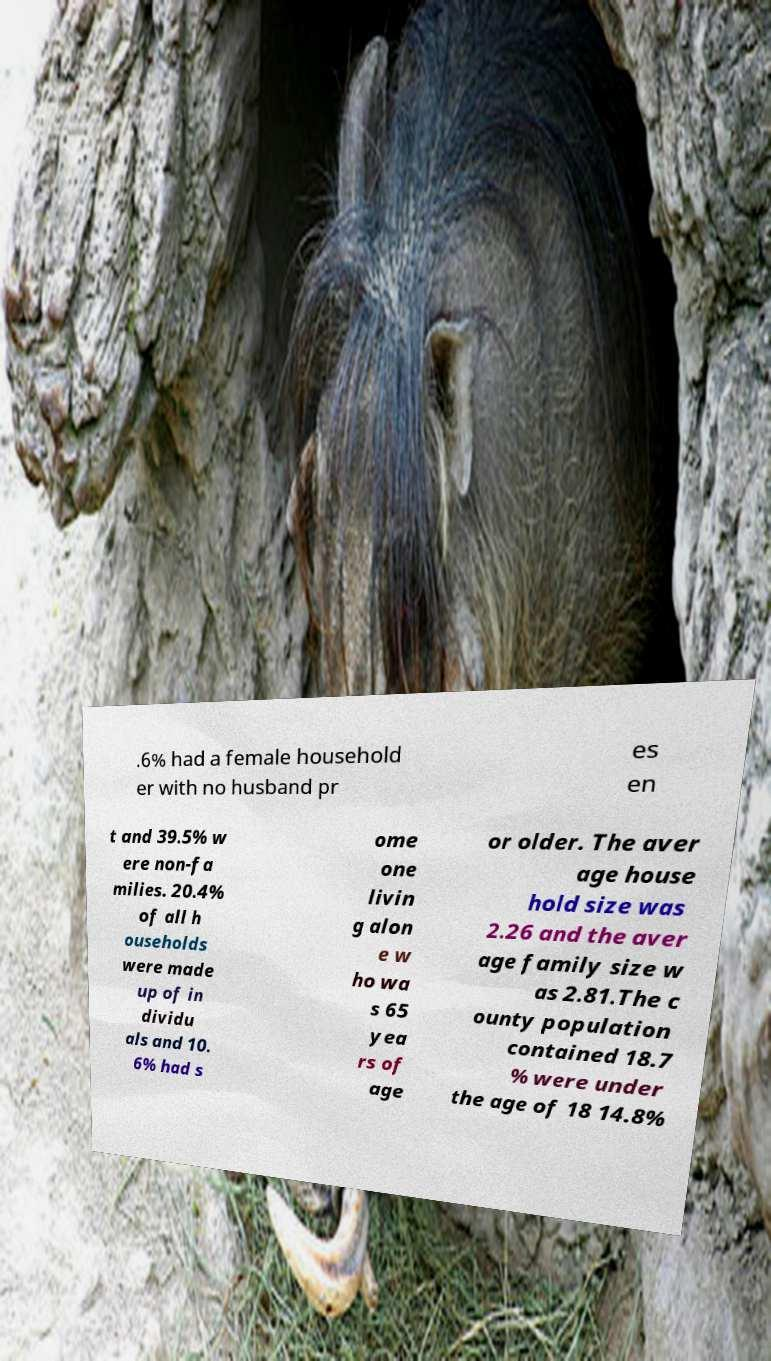Please identify and transcribe the text found in this image. .6% had a female household er with no husband pr es en t and 39.5% w ere non-fa milies. 20.4% of all h ouseholds were made up of in dividu als and 10. 6% had s ome one livin g alon e w ho wa s 65 yea rs of age or older. The aver age house hold size was 2.26 and the aver age family size w as 2.81.The c ounty population contained 18.7 % were under the age of 18 14.8% 